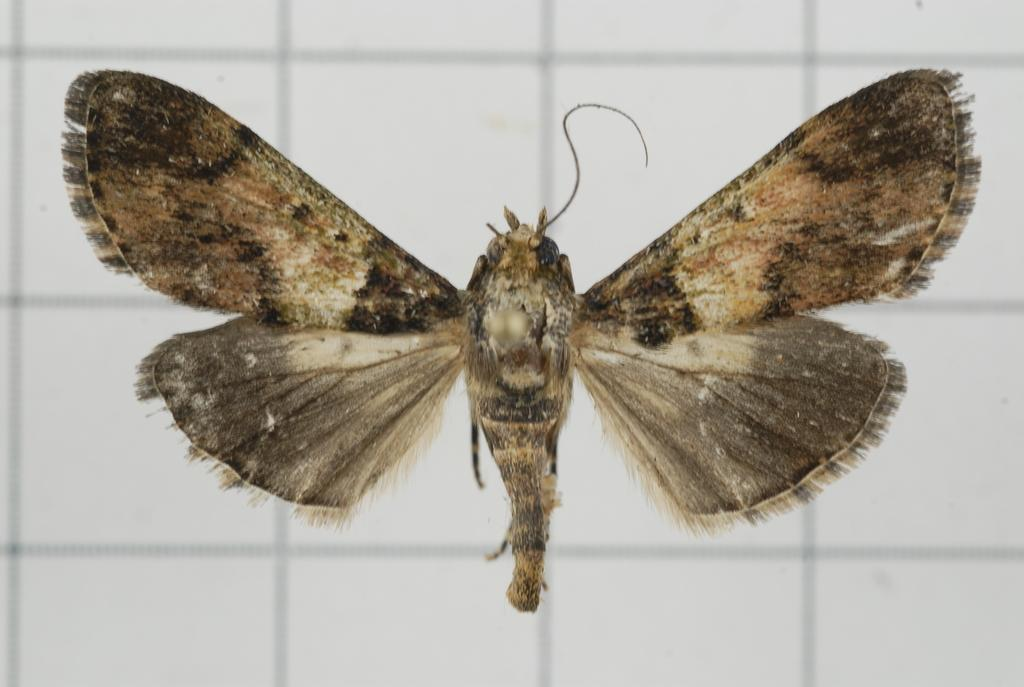What is the main subject in the center of the image? There is a fly in the center of the image. What can be seen in the background of the image? There is a wall in the background of the image. What type of money is being exchanged in the image? There is no money or exchange of money present in the image; it features a fly and a wall. What kind of competition is taking place in the image? There is no competition present in the image; it features a fly and a wall. 